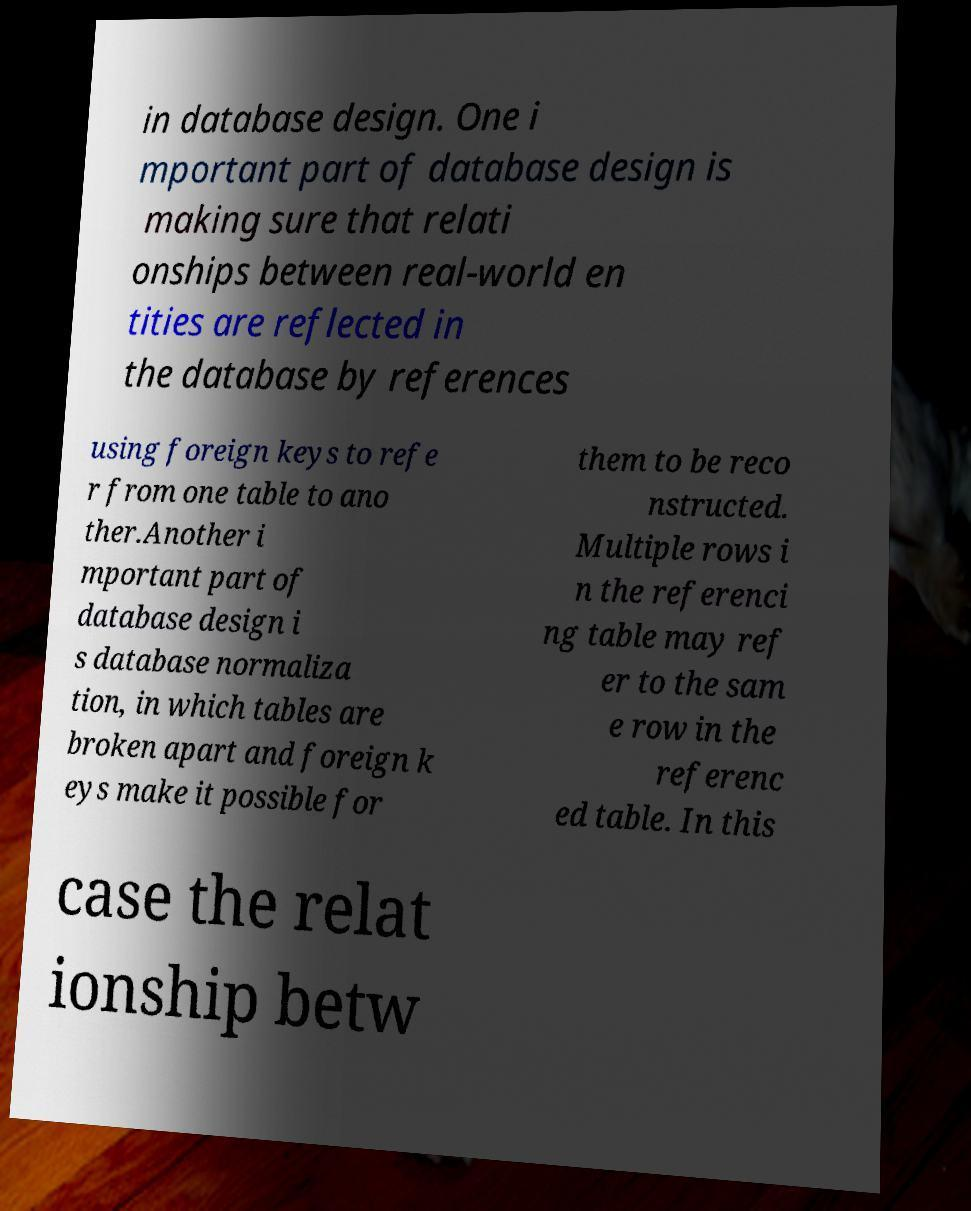For documentation purposes, I need the text within this image transcribed. Could you provide that? in database design. One i mportant part of database design is making sure that relati onships between real-world en tities are reflected in the database by references using foreign keys to refe r from one table to ano ther.Another i mportant part of database design i s database normaliza tion, in which tables are broken apart and foreign k eys make it possible for them to be reco nstructed. Multiple rows i n the referenci ng table may ref er to the sam e row in the referenc ed table. In this case the relat ionship betw 